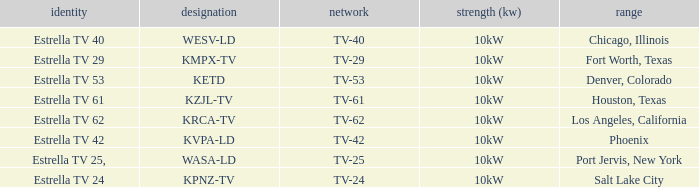List the power output for Phoenix.  10kW. 